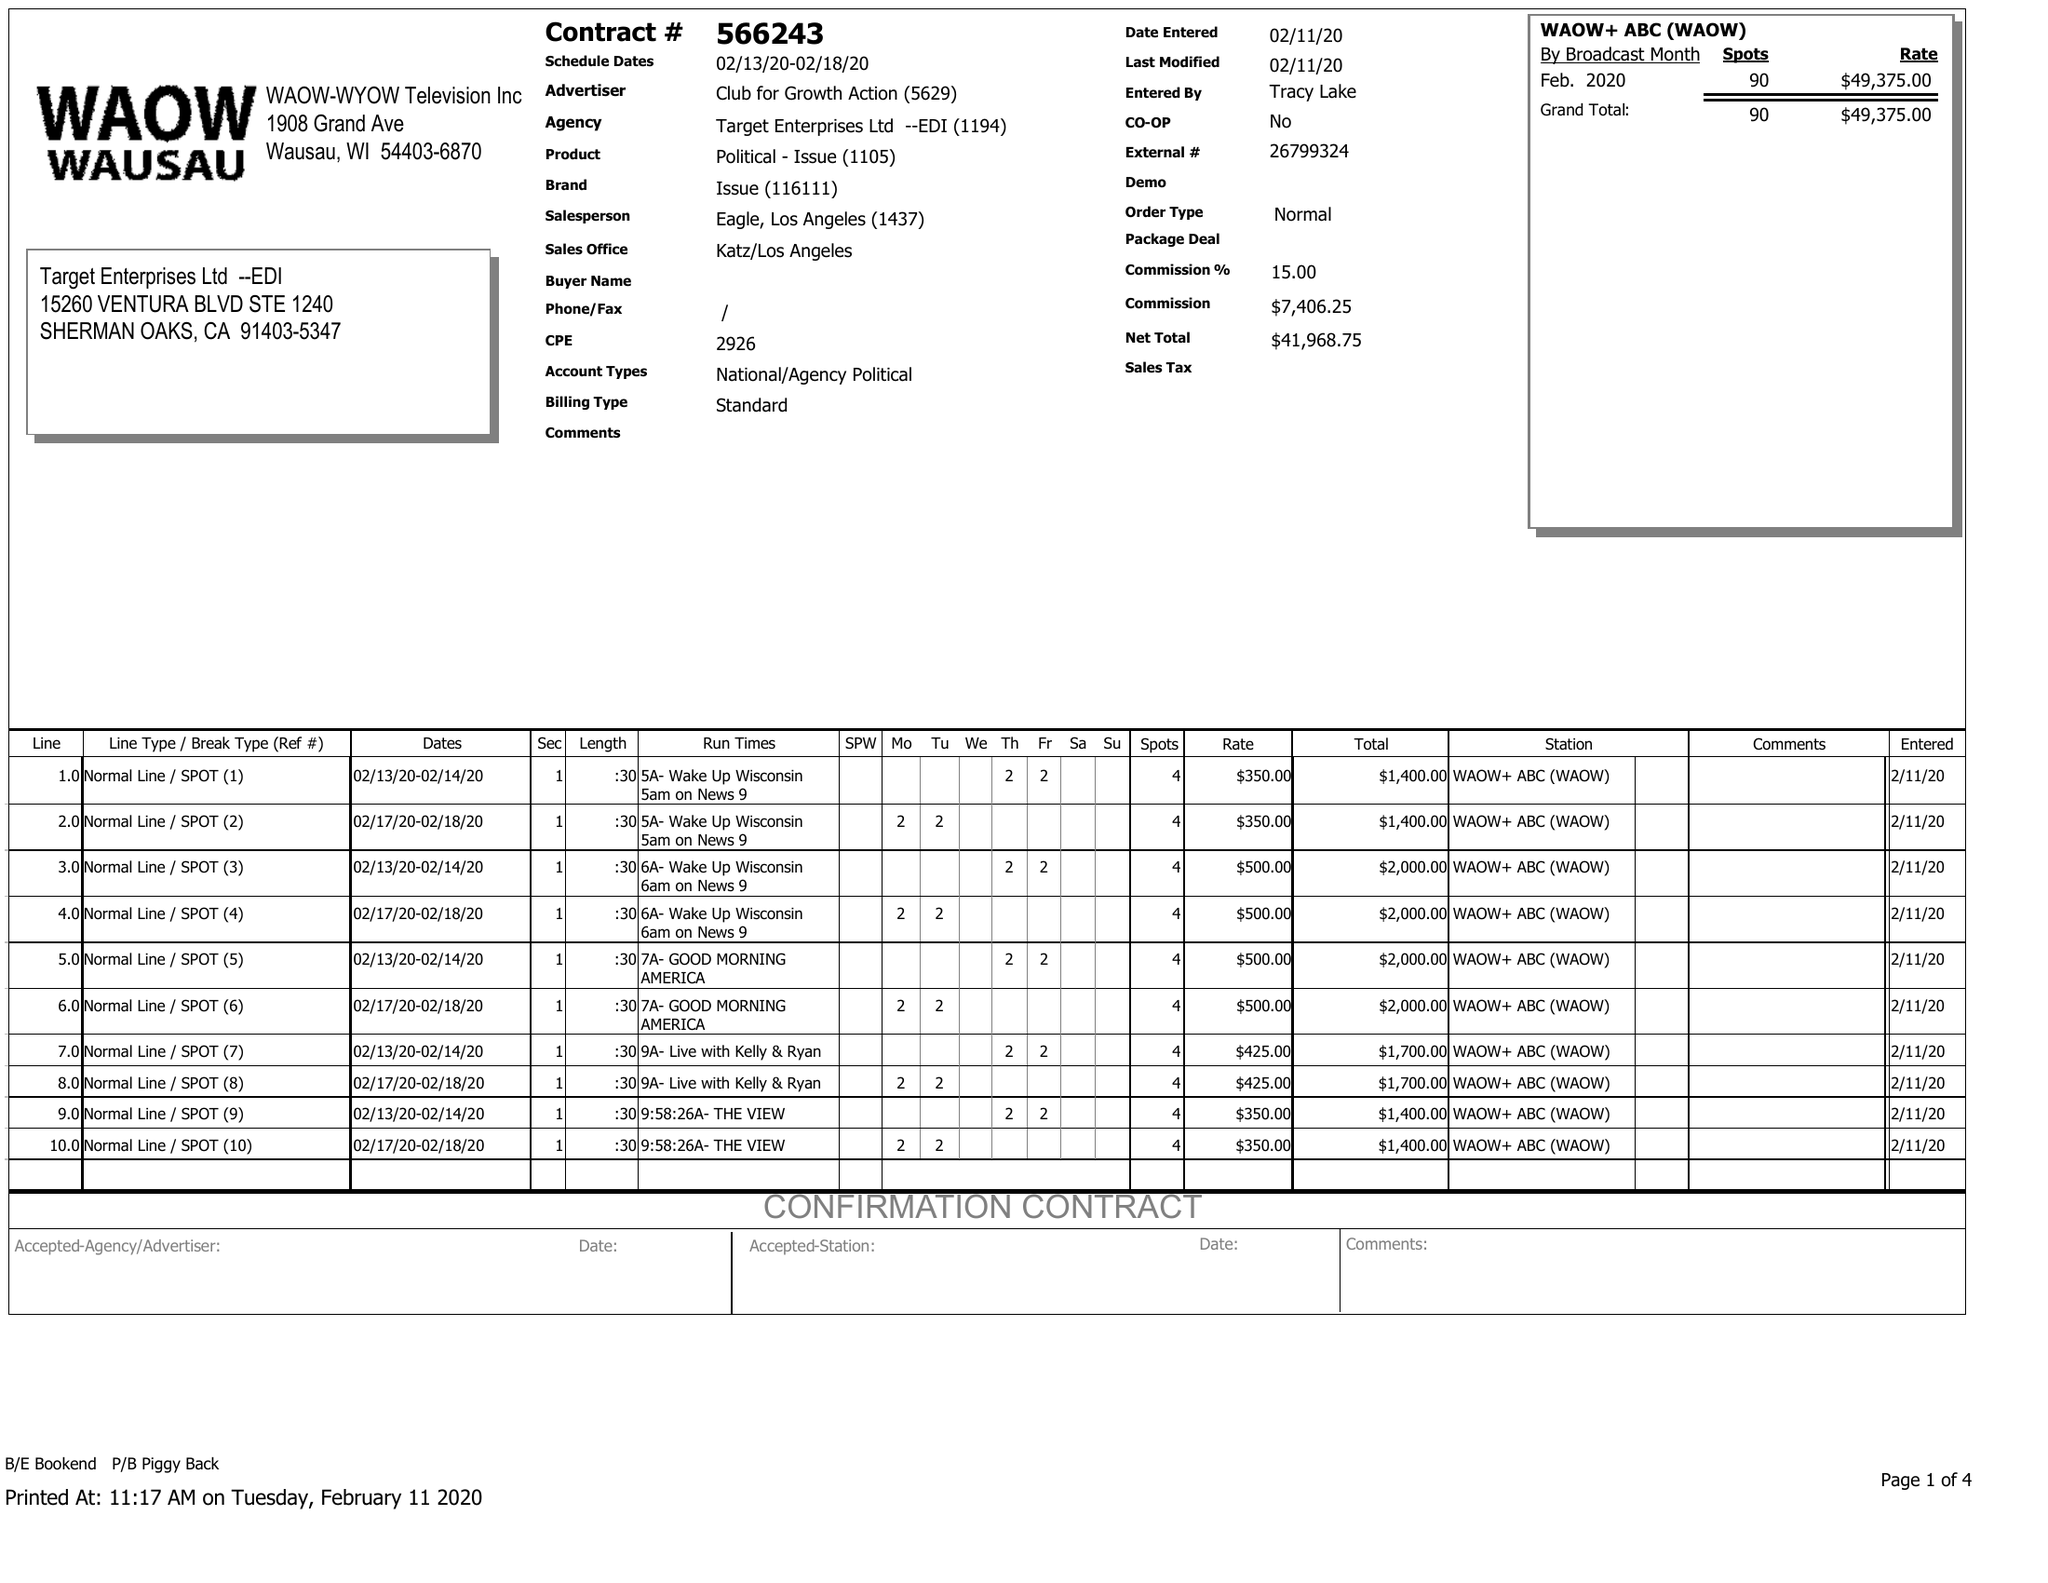What is the value for the gross_amount?
Answer the question using a single word or phrase. 49375.00 